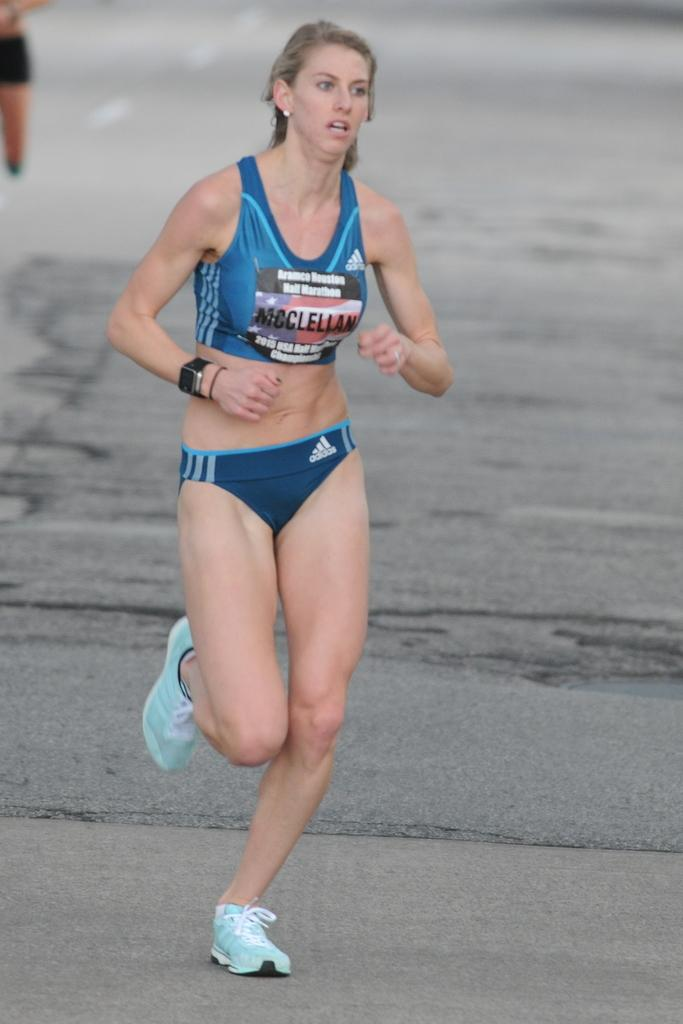<image>
Provide a brief description of the given image. A female runner in a marathon wearing a two piece apparel from Addidas. 